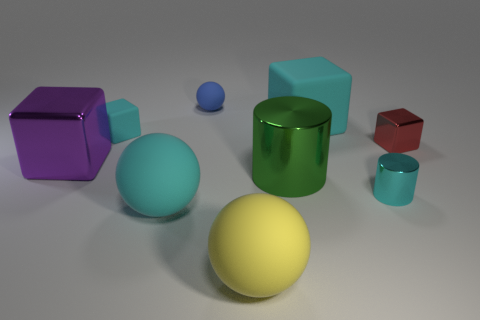How many big rubber spheres are the same color as the small cylinder?
Provide a short and direct response. 1. The sphere that is the same color as the small shiny cylinder is what size?
Give a very brief answer. Large. What number of blue things are shiny cylinders or small metal objects?
Make the answer very short. 0. What number of small cyan matte objects are in front of the cyan block that is right of the big green object?
Provide a succinct answer. 1. Are there any other things of the same color as the large metal block?
Your response must be concise. No. There is a purple thing that is the same material as the red thing; what is its shape?
Give a very brief answer. Cube. Do the large cylinder and the tiny rubber sphere have the same color?
Provide a short and direct response. No. Is the material of the tiny block on the left side of the large yellow rubber ball the same as the big cube that is on the left side of the cyan ball?
Provide a succinct answer. No. What number of things are either spheres or metal objects that are in front of the big purple block?
Offer a very short reply. 5. Is there anything else that is made of the same material as the green thing?
Your response must be concise. Yes. 